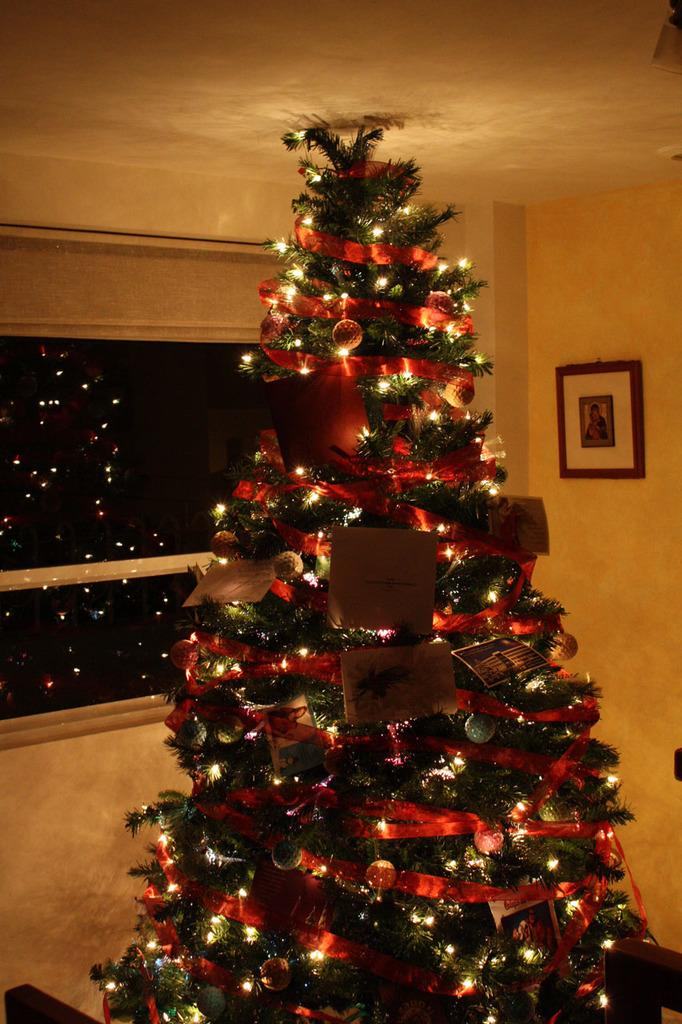What is the main object in the image? There is a Christmas tree in the image. What decorations are on the Christmas tree? The Christmas tree has lights and cards. What can be seen in the background of the image? There is a window and a frame on the wall in the background of the image. What type of boat is visible in the image? There is no boat present in the image; it features a Christmas tree with lights and cards, along with a window and a frame on the wall in the background. 